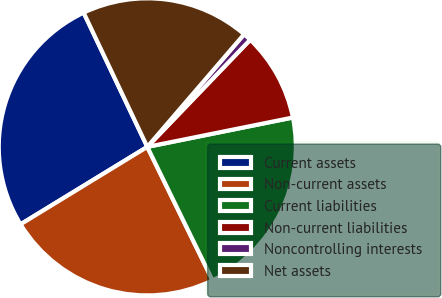<chart> <loc_0><loc_0><loc_500><loc_500><pie_chart><fcel>Current assets<fcel>Non-current assets<fcel>Current liabilities<fcel>Non-current liabilities<fcel>Noncontrolling interests<fcel>Net assets<nl><fcel>26.68%<fcel>23.51%<fcel>20.93%<fcel>9.65%<fcel>0.88%<fcel>18.35%<nl></chart> 